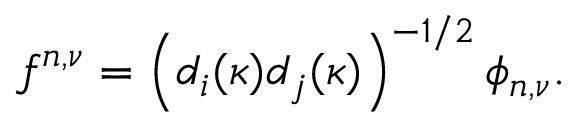Convert formula to latex. <formula><loc_0><loc_0><loc_500><loc_500>f ^ { n , \nu } = \left ( d _ { i } ( \kappa ) d _ { j } ( \kappa ) \right ) ^ { - 1 / 2 } \phi _ { n , \nu } .</formula> 